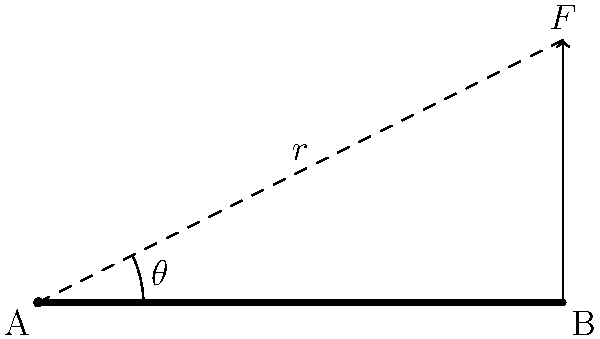En un sistema de palanca simple que representa el movimiento del brazo humano, como se muestra en la figura, el brazo está extendido horizontalmente y se aplica una fuerza vertical $F$ en el extremo. Si el ángulo entre el brazo y la línea de acción de la fuerza es $\theta = 30°$, ¿cuál es la expresión para el momento de fuerza en función de la longitud del brazo $L$ y la magnitud de la fuerza $F$? Para resolver este problema, seguiremos estos pasos:

1) El momento de fuerza se calcula como el producto de la fuerza y el brazo de momento:

   $$M = F \cdot r$$

   donde $M$ es el momento, $F$ es la magnitud de la fuerza, y $r$ es el brazo de momento.

2) El brazo de momento es la distancia perpendicular desde el eje de rotación (en este caso, el codo) hasta la línea de acción de la fuerza.

3) En este caso, el brazo de momento $r$ no es igual a la longitud total del brazo $L$. Necesitamos calcular $r$ usando trigonometría.

4) Observamos que el brazo de momento $r$ y la longitud del brazo $L$ forman un triángulo rectángulo con el ángulo $\theta$.

5) En este triángulo rectángulo, $r$ es el cateto opuesto al ángulo $\theta$, y $L$ es la hipotenusa.

6) La relación trigonométrica que relaciona el cateto opuesto con la hipotenusa es el seno:

   $$\sin \theta = \frac{r}{L}$$

7) Despejando $r$:

   $$r = L \sin \theta$$

8) Sustituyendo esto en la ecuación del momento:

   $$M = F \cdot r = F \cdot L \sin \theta$$

9) Por lo tanto, la expresión para el momento de fuerza es $F \cdot L \sin 30°$.

10) Sabemos que $\sin 30° = \frac{1}{2}$, por lo que podríamos simplificar aún más la expresión a $\frac{1}{2}FL$, pero la pregunta pide la expresión en función de $L$ y $F$, así que mantendremos $\sin 30°$.
Answer: $F \cdot L \sin 30°$ 